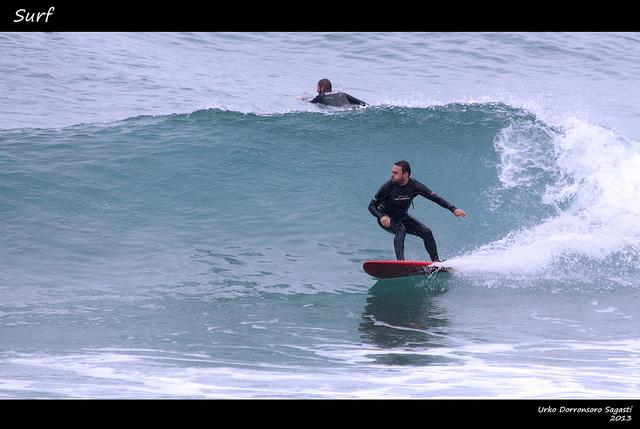Why does the man on the surf board crouch? Please explain your reasoning. improved balance. A surfer is riding a wave on top of the surfboard with knees slightly ben and arms out. 